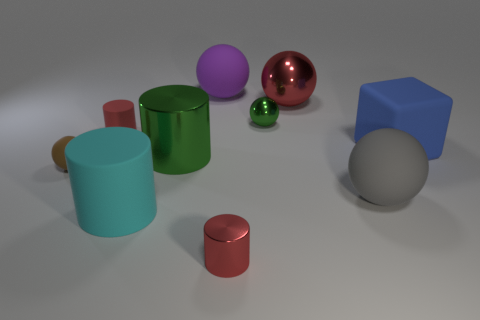Subtract all large matte balls. How many balls are left? 3 Subtract all green spheres. How many red cylinders are left? 2 Subtract 1 spheres. How many spheres are left? 4 Subtract all brown balls. How many balls are left? 4 Subtract all blocks. How many objects are left? 9 Add 4 green things. How many green things are left? 6 Add 9 big purple rubber spheres. How many big purple rubber spheres exist? 10 Subtract 1 gray balls. How many objects are left? 9 Subtract all gray spheres. Subtract all purple cylinders. How many spheres are left? 4 Subtract all matte objects. Subtract all big blocks. How many objects are left? 3 